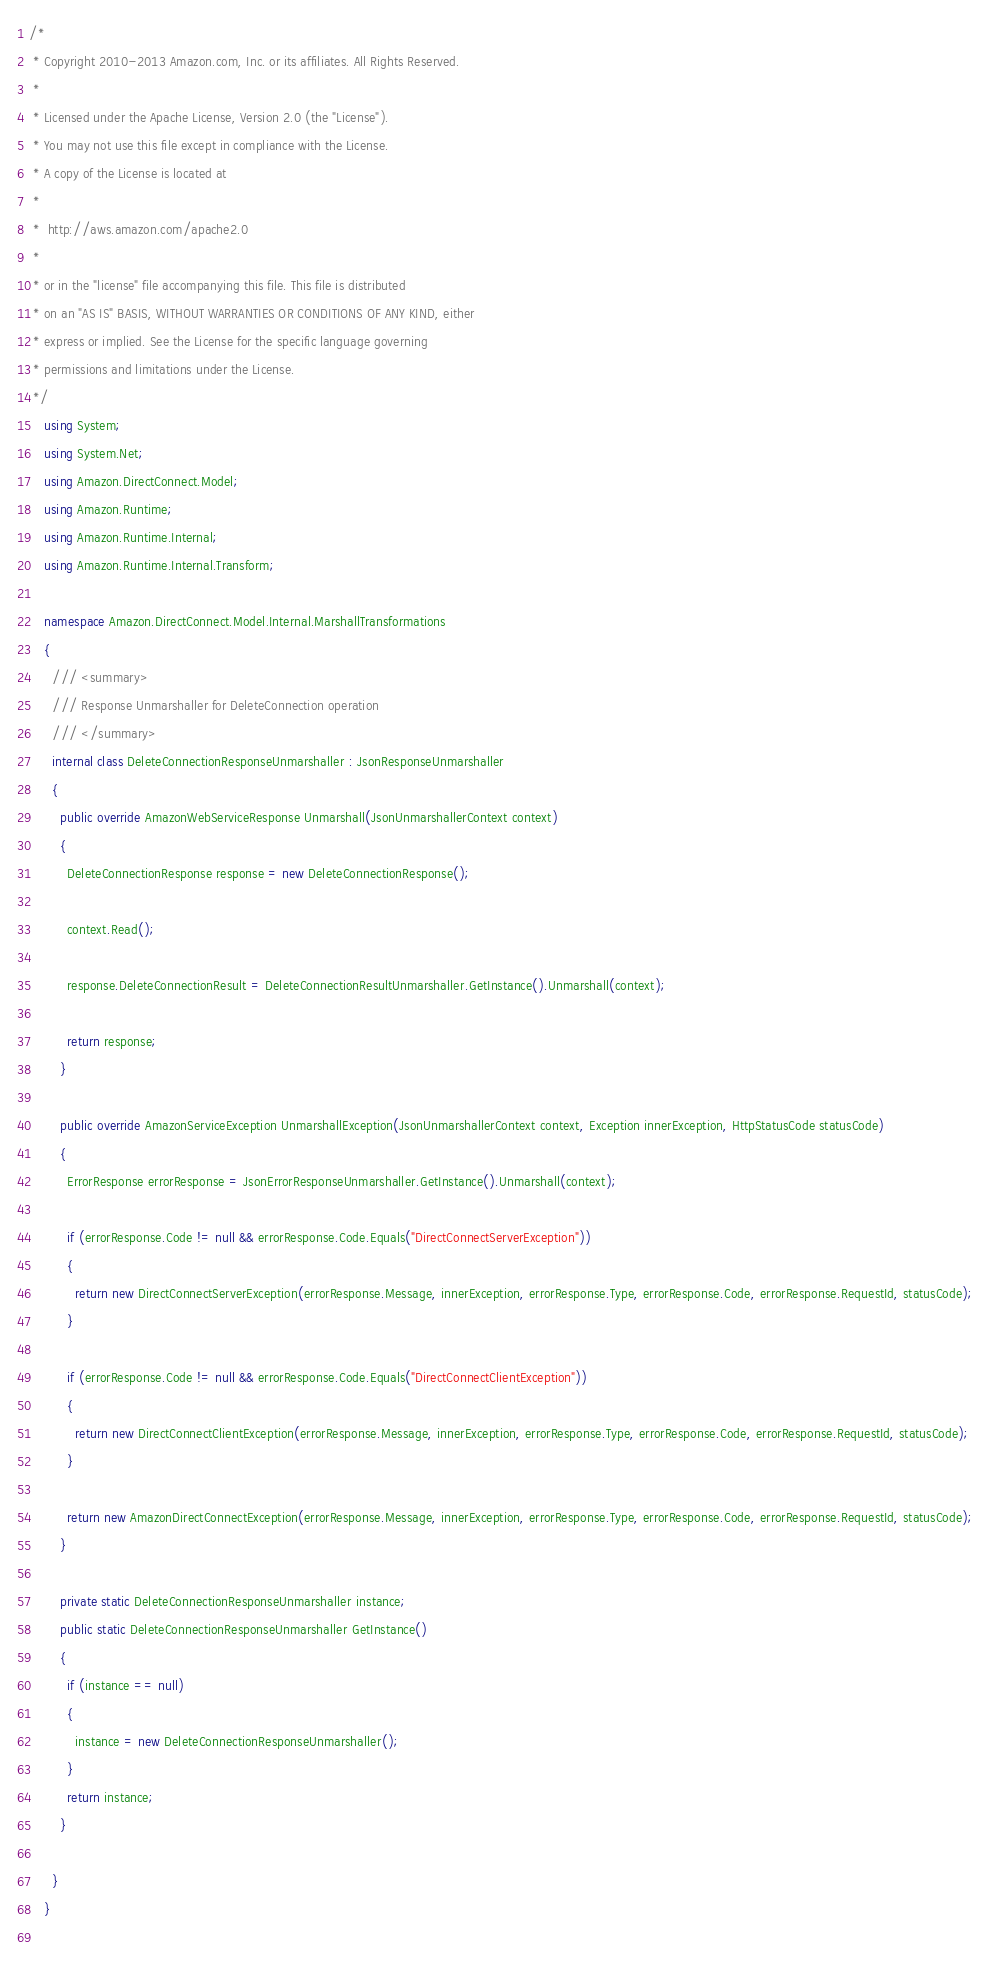<code> <loc_0><loc_0><loc_500><loc_500><_C#_>/*
 * Copyright 2010-2013 Amazon.com, Inc. or its affiliates. All Rights Reserved.
 * 
 * Licensed under the Apache License, Version 2.0 (the "License").
 * You may not use this file except in compliance with the License.
 * A copy of the License is located at
 * 
 *  http://aws.amazon.com/apache2.0
 * 
 * or in the "license" file accompanying this file. This file is distributed
 * on an "AS IS" BASIS, WITHOUT WARRANTIES OR CONDITIONS OF ANY KIND, either
 * express or implied. See the License for the specific language governing
 * permissions and limitations under the License.
 */ 
    using System; 
    using System.Net;
    using Amazon.DirectConnect.Model; 
    using Amazon.Runtime; 
    using Amazon.Runtime.Internal; 
    using Amazon.Runtime.Internal.Transform; 
    
    namespace Amazon.DirectConnect.Model.Internal.MarshallTransformations 
    { 
      /// <summary> 
      /// Response Unmarshaller for DeleteConnection operation 
      /// </summary> 
      internal class DeleteConnectionResponseUnmarshaller : JsonResponseUnmarshaller 
      { 
        public override AmazonWebServiceResponse Unmarshall(JsonUnmarshallerContext context) 
        { 
          DeleteConnectionResponse response = new DeleteConnectionResponse();
          
          context.Read();
      
          response.DeleteConnectionResult = DeleteConnectionResultUnmarshaller.GetInstance().Unmarshall(context); 
           
          return response; 
        } 
         
        public override AmazonServiceException UnmarshallException(JsonUnmarshallerContext context, Exception innerException, HttpStatusCode statusCode) 
        { 
          ErrorResponse errorResponse = JsonErrorResponseUnmarshaller.GetInstance().Unmarshall(context); 
           
          if (errorResponse.Code != null && errorResponse.Code.Equals("DirectConnectServerException")) 
          { 
            return new DirectConnectServerException(errorResponse.Message, innerException, errorResponse.Type, errorResponse.Code, errorResponse.RequestId, statusCode); 
          } 
   
          if (errorResponse.Code != null && errorResponse.Code.Equals("DirectConnectClientException")) 
          { 
            return new DirectConnectClientException(errorResponse.Message, innerException, errorResponse.Type, errorResponse.Code, errorResponse.RequestId, statusCode); 
          } 
   
          return new AmazonDirectConnectException(errorResponse.Message, innerException, errorResponse.Type, errorResponse.Code, errorResponse.RequestId, statusCode); 
        } 
  
        private static DeleteConnectionResponseUnmarshaller instance; 
        public static DeleteConnectionResponseUnmarshaller GetInstance() 
        { 
          if (instance == null) 
          { 
            instance = new DeleteConnectionResponseUnmarshaller(); 
          } 
          return instance;
        } 
  
      } 
    } 
  
</code> 